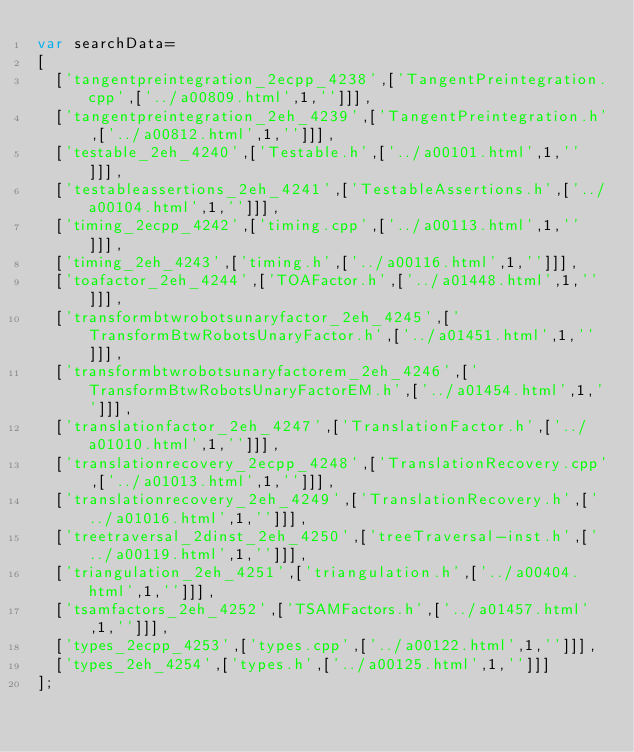<code> <loc_0><loc_0><loc_500><loc_500><_JavaScript_>var searchData=
[
  ['tangentpreintegration_2ecpp_4238',['TangentPreintegration.cpp',['../a00809.html',1,'']]],
  ['tangentpreintegration_2eh_4239',['TangentPreintegration.h',['../a00812.html',1,'']]],
  ['testable_2eh_4240',['Testable.h',['../a00101.html',1,'']]],
  ['testableassertions_2eh_4241',['TestableAssertions.h',['../a00104.html',1,'']]],
  ['timing_2ecpp_4242',['timing.cpp',['../a00113.html',1,'']]],
  ['timing_2eh_4243',['timing.h',['../a00116.html',1,'']]],
  ['toafactor_2eh_4244',['TOAFactor.h',['../a01448.html',1,'']]],
  ['transformbtwrobotsunaryfactor_2eh_4245',['TransformBtwRobotsUnaryFactor.h',['../a01451.html',1,'']]],
  ['transformbtwrobotsunaryfactorem_2eh_4246',['TransformBtwRobotsUnaryFactorEM.h',['../a01454.html',1,'']]],
  ['translationfactor_2eh_4247',['TranslationFactor.h',['../a01010.html',1,'']]],
  ['translationrecovery_2ecpp_4248',['TranslationRecovery.cpp',['../a01013.html',1,'']]],
  ['translationrecovery_2eh_4249',['TranslationRecovery.h',['../a01016.html',1,'']]],
  ['treetraversal_2dinst_2eh_4250',['treeTraversal-inst.h',['../a00119.html',1,'']]],
  ['triangulation_2eh_4251',['triangulation.h',['../a00404.html',1,'']]],
  ['tsamfactors_2eh_4252',['TSAMFactors.h',['../a01457.html',1,'']]],
  ['types_2ecpp_4253',['types.cpp',['../a00122.html',1,'']]],
  ['types_2eh_4254',['types.h',['../a00125.html',1,'']]]
];
</code> 